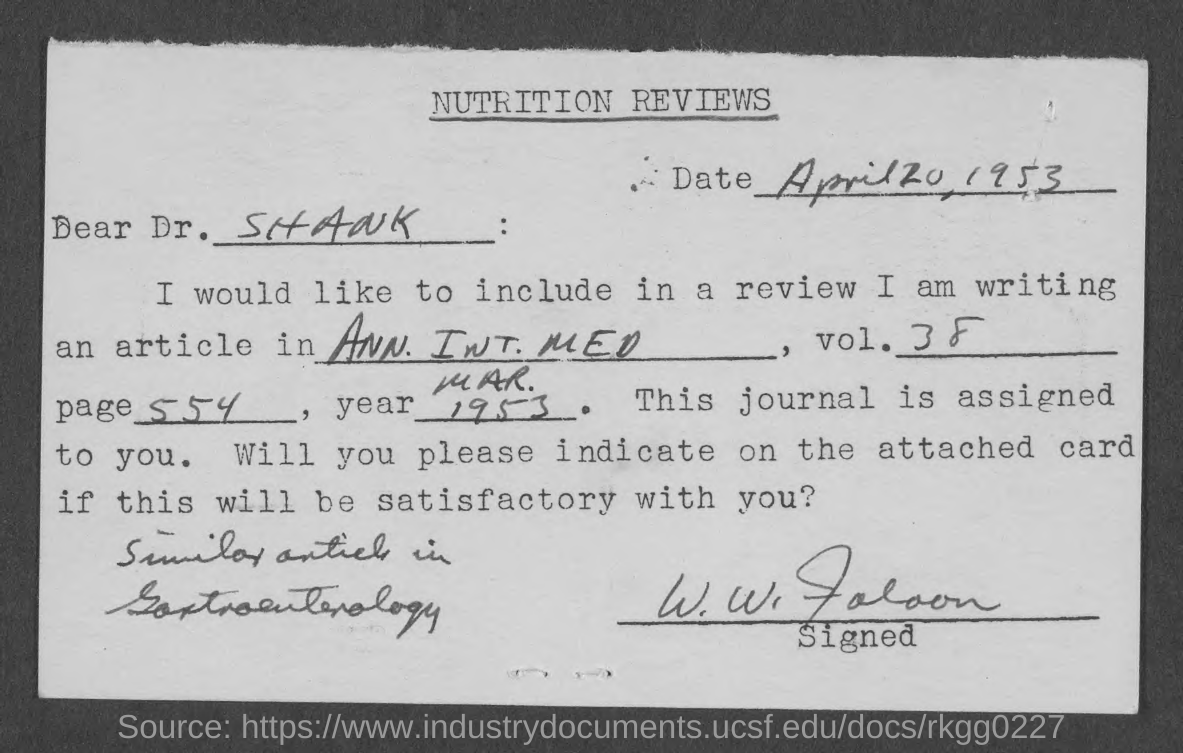What is the Date mentioned in the to[p of the document ?
Keep it short and to the point. April 20, 1953. 